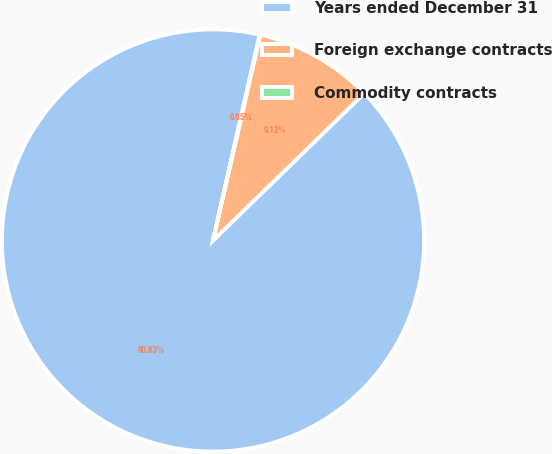<chart> <loc_0><loc_0><loc_500><loc_500><pie_chart><fcel>Years ended December 31<fcel>Foreign exchange contracts<fcel>Commodity contracts<nl><fcel>90.83%<fcel>9.12%<fcel>0.05%<nl></chart> 